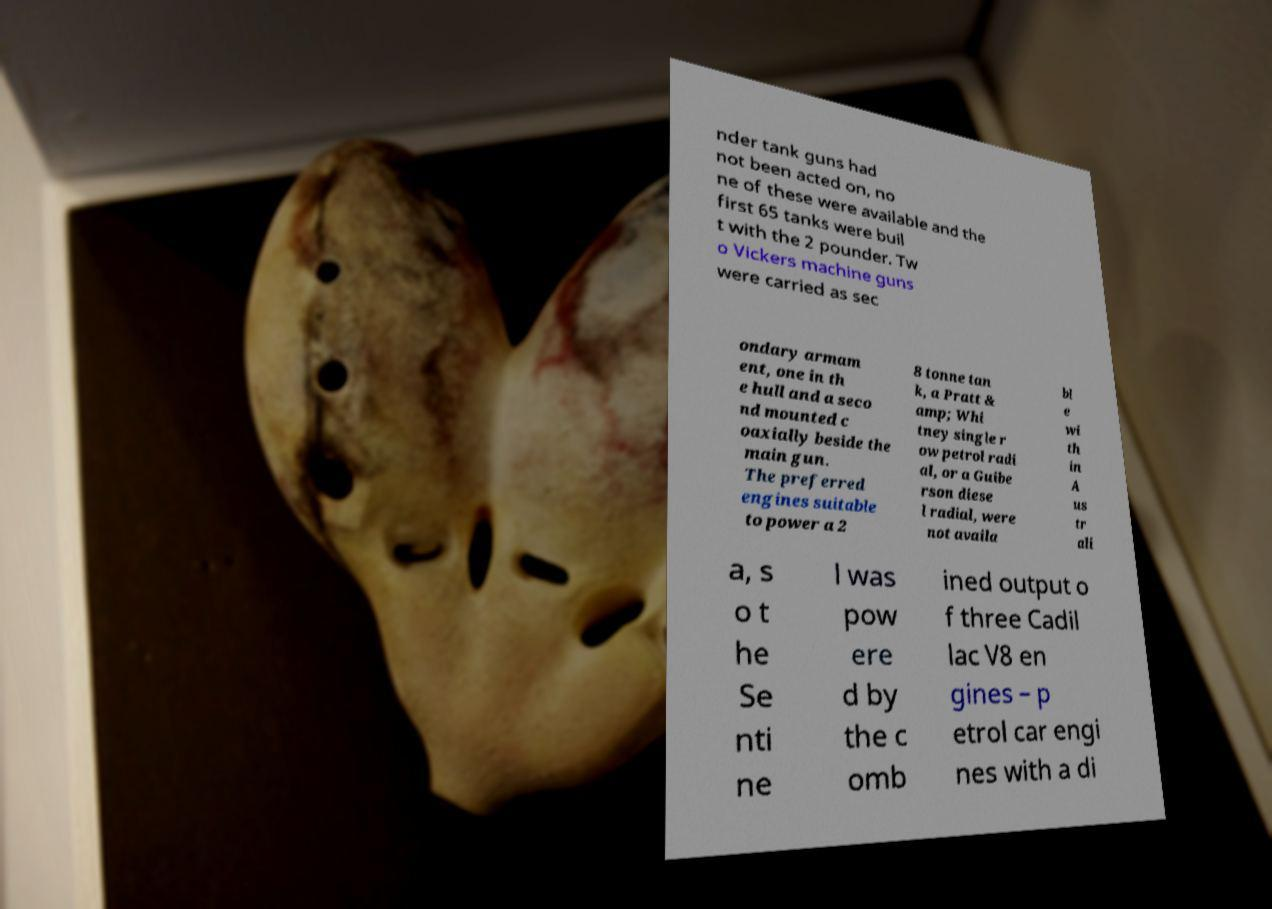Please identify and transcribe the text found in this image. nder tank guns had not been acted on, no ne of these were available and the first 65 tanks were buil t with the 2 pounder. Tw o Vickers machine guns were carried as sec ondary armam ent, one in th e hull and a seco nd mounted c oaxially beside the main gun. The preferred engines suitable to power a 2 8 tonne tan k, a Pratt & amp; Whi tney single r ow petrol radi al, or a Guibe rson diese l radial, were not availa bl e wi th in A us tr ali a, s o t he Se nti ne l was pow ere d by the c omb ined output o f three Cadil lac V8 en gines – p etrol car engi nes with a di 